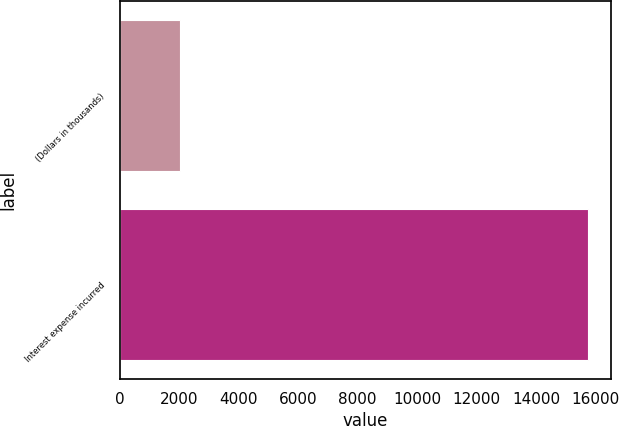Convert chart. <chart><loc_0><loc_0><loc_500><loc_500><bar_chart><fcel>(Dollars in thousands)<fcel>Interest expense incurred<nl><fcel>2013<fcel>15748<nl></chart> 